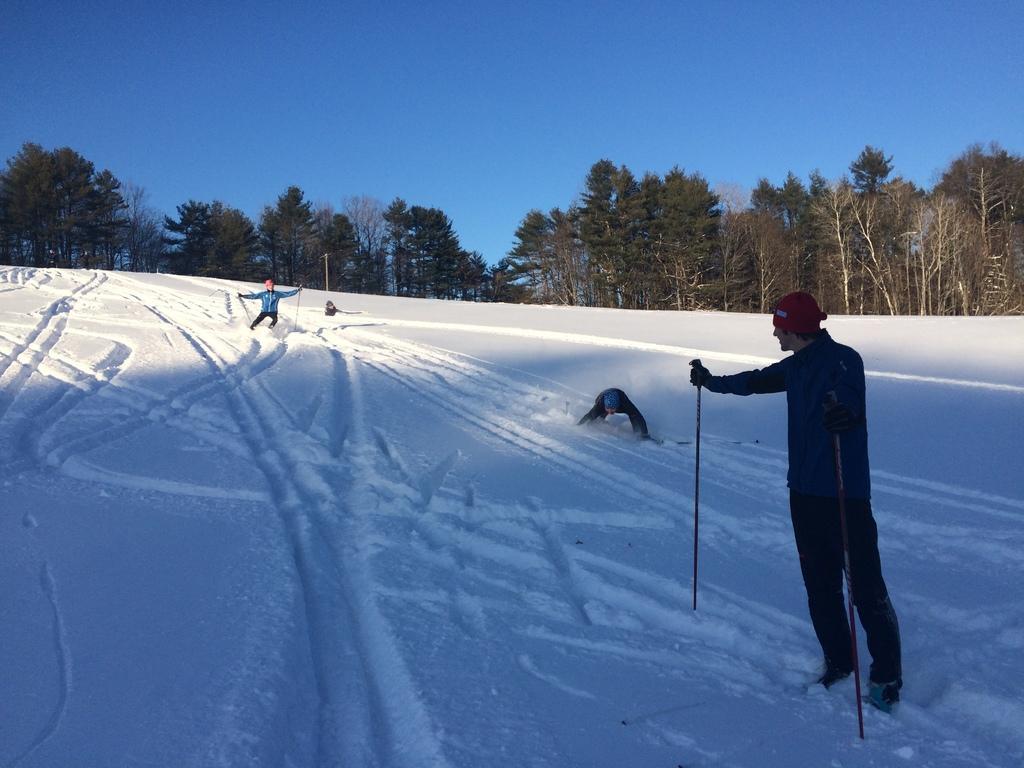How would you summarize this image in a sentence or two? In this image, there are a few people. Among them, two people are holding some objects. We can see the ground covered with snow. There are a few trees. We can see a pole and the sky. 